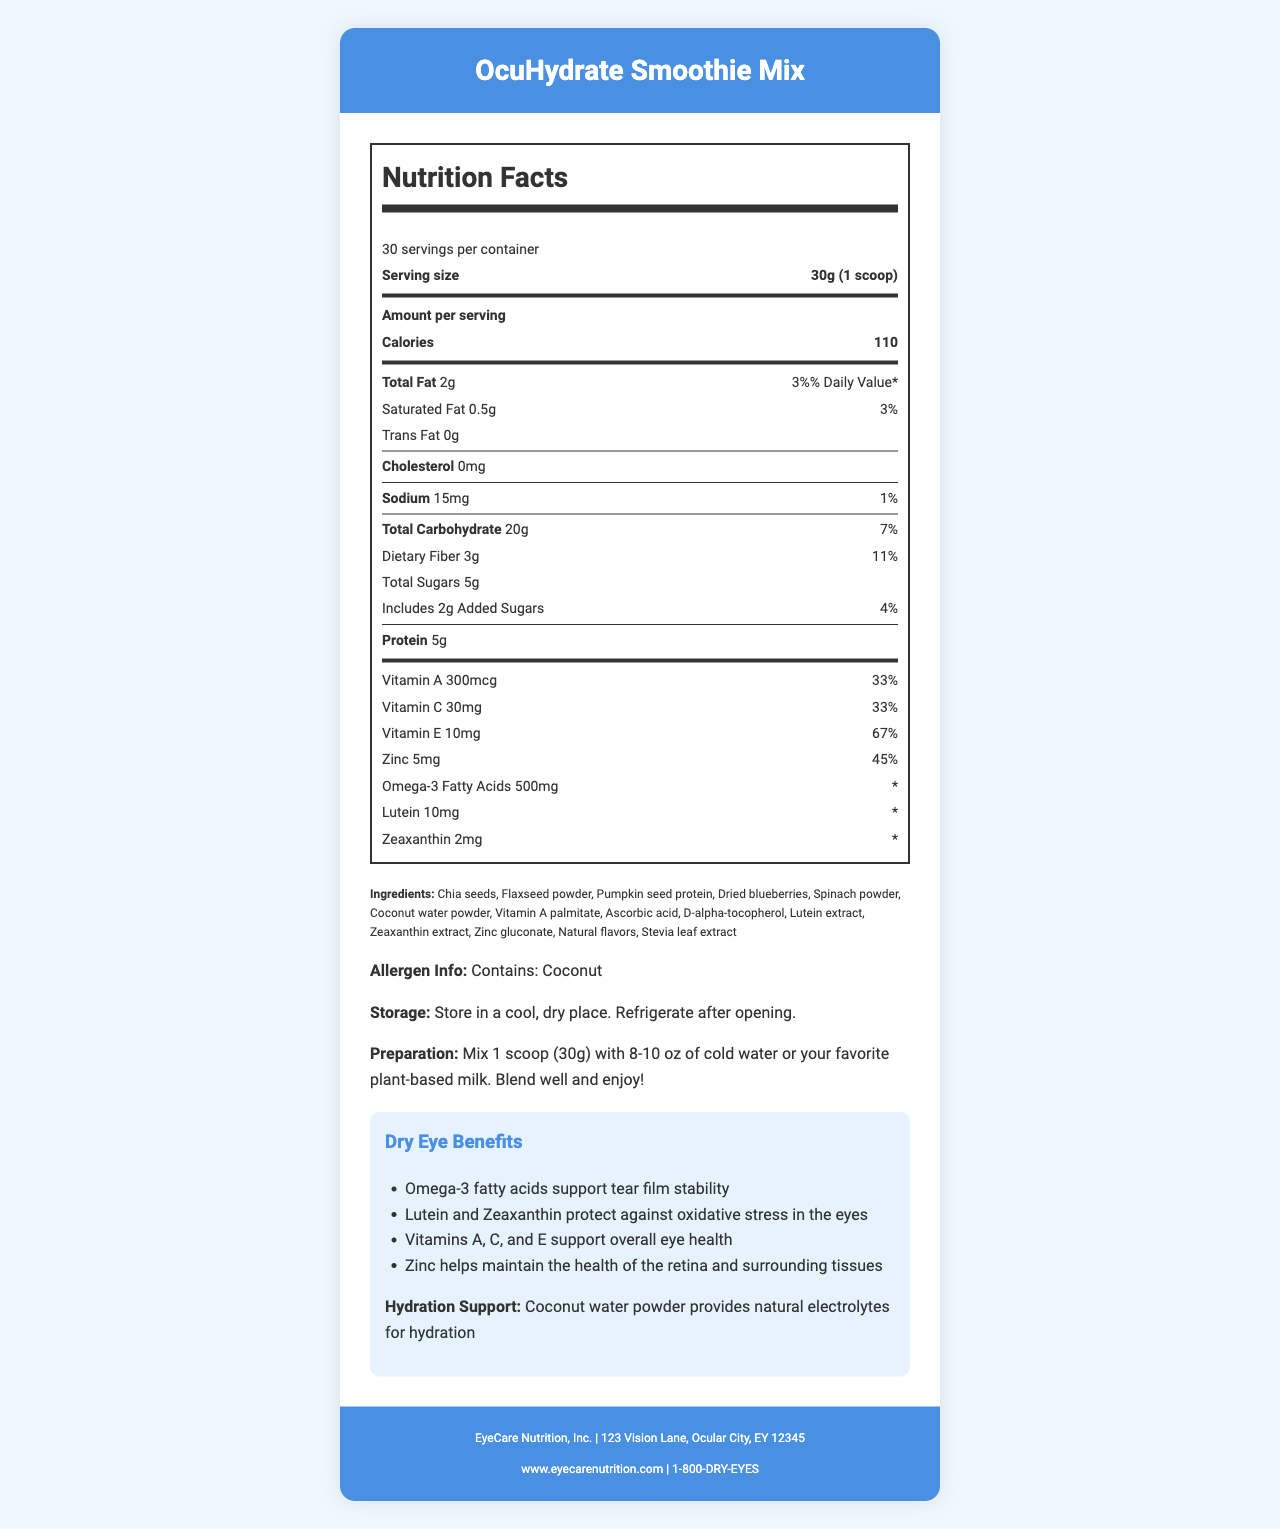what is the serving size of the OcuHydrate Smoothie Mix? The serving size is specified as "30g (1 scoop)" in the Nutrition Facts Label.
Answer: 30g (1 scoop) how many calories are in one serving of the smoothie mix? The number of calories per serving is directly listed as "110" on the label.
Answer: 110 calories how much saturated fat is in a serving of the smoothie mix? The amount of saturated fat is listed as "0.5g" in the Total Fat section of the label.
Answer: 0.5g what percentage of the Daily Value of Vitamin A does one serving provide? The Daily Value for Vitamin A is listed as 33% on the label.
Answer: 33% how many milligrams of Vitamin E are in one serving? The amount of Vitamin E per serving is listed as "10mg" on the label.
Answer: 10mg which ingredient provides natural electrolytes for hydration? A. Spinach powder B. Coconut water powder C. Flaxseed powder The document states that "Coconut water powder provides natural electrolytes for hydration."
Answer: B how many grams of dietary fiber are in one serving? A. 2g B. 3g C. 5g The amount of dietary fiber per serving is listed as "3g" in the Total Carbohydrate section.
Answer: B what is the preparation instruction for the smoothie mix? The preparation instruction is given under the section titled "Preparation" on the document.
Answer: Mix 1 scoop (30g) with 8-10 oz of cold water or your favorite plant-based milk. Blend well and enjoy! does the product contain any trans fat? The amount of trans fat is listed as "0g," indicating that the product does not contain any trans fat.
Answer: No describe the main idea of the document The document includes the product name, serving size, calories, macronutrient details, vitamins, minerals, specific ingredients list, allergen information, storage and preparation instructions, and benefits for dry eye and hydration. It also includes manufacturer information.
Answer: The document provides detailed nutrition information, ingredients, benefits, and usage instructions for OcuHydrate Smoothie Mix, a product designed to support dry eye relief and hydration. what is the exact address of the manufacturer? The manufacturer address is listed under the footer, stating "123 Vision Lane, Ocular City, EY 12345."
Answer: 123 Vision Lane, Ocular City, EY 12345 how many servings per container are there? The number of servings per container is specified as "30" in the Nutrition Facts Label.
Answer: 30 does the product contain any cholesterol? The amount of cholesterol in the product is listed as "0mg," indicating there is no cholesterol.
Answer: No what are the benefits of omega-3 fatty acids in the smoothie mix? One of the dry eye benefits listed mentions that Omega-3 fatty acids support tear film stability.
Answer: Supports tear film stability how much zinc does one serving of the smoothie mix contain? The amount of zinc per serving is specified as "5mg" on the label.
Answer: 5mg how much total carbohydrate is in one serving? The total carbohydrate content per serving is listed as "20g" in the Nutrition Facts Label.
Answer: 20g list the vitamins and minerals included in the smoothie mix that support overall eye health. The dry eye benefits section mentions that Vitamins A, C, and E, and Zinc support overall eye health.
Answer: Vitamins A, C, and E, and Zinc what is the contact phone number for the manufacturer? The manufacturer's contact phone number is provided in the footer as "1-800-DRY-EYES."
Answer: 1-800-DRY-EYES what flavoring agents are used in the smoothie mix? The ingredients section lists "Natural flavors" and "Stevia leaf extract" as flavoring agents.
Answer: Natural flavors, Stevia leaf extract how many different vitamins are listed in the nutrition facts? The Nutrition Facts section lists Vitamin A, Vitamin C, and Vitamin E.
Answer: Three: Vitamin A, Vitamin C, and Vitamin E which ingredient provides the most protein? Among the listed ingredients, "Pumpkin seed protein" is specified, which is a significant source of protein.
Answer: Pumpkin seed protein can we determine the exact blend of plant-based milk to use? The preparation instructions mention using "your favorite plant-based milk" without specifying a particular type.
Answer: No, the choice is left to personal preference. 